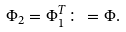<formula> <loc_0><loc_0><loc_500><loc_500>\Phi _ { 2 } = \Phi _ { 1 } ^ { T } \colon = \Phi .</formula> 